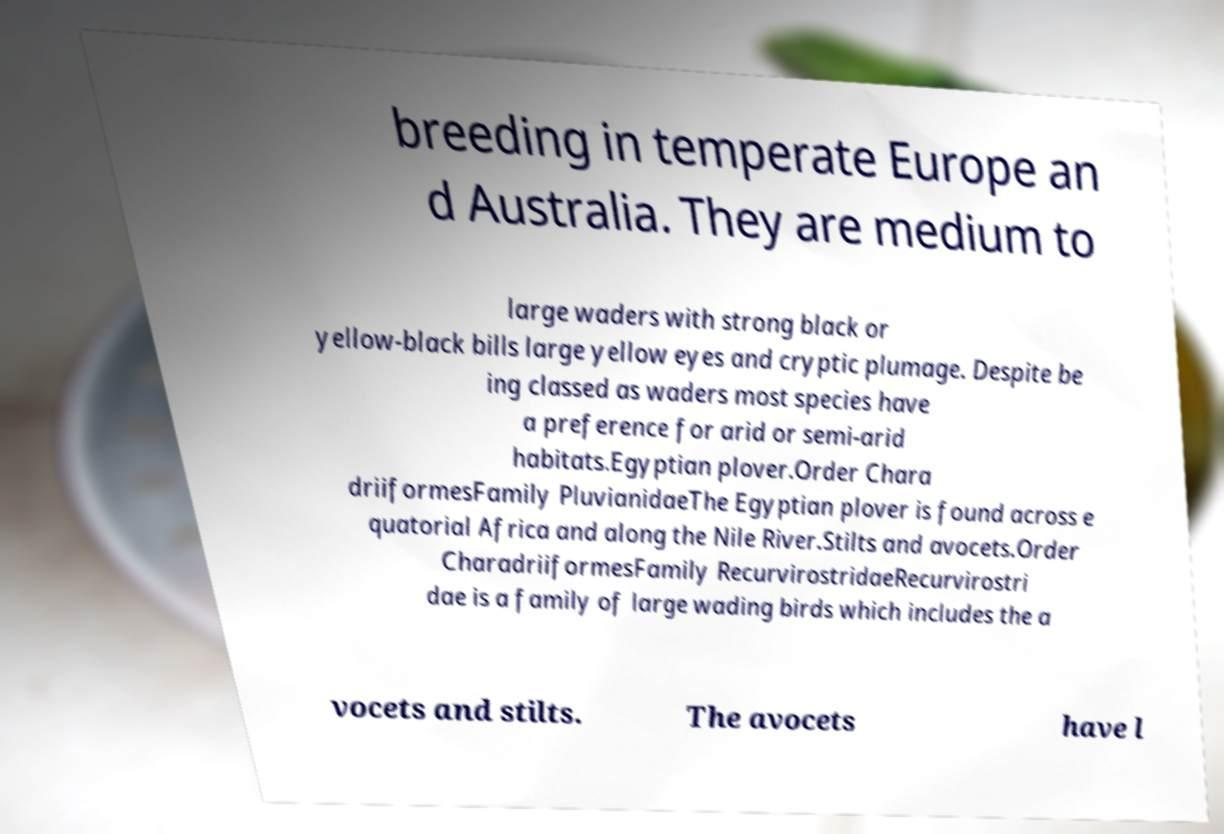Could you assist in decoding the text presented in this image and type it out clearly? breeding in temperate Europe an d Australia. They are medium to large waders with strong black or yellow-black bills large yellow eyes and cryptic plumage. Despite be ing classed as waders most species have a preference for arid or semi-arid habitats.Egyptian plover.Order Chara driiformesFamily PluvianidaeThe Egyptian plover is found across e quatorial Africa and along the Nile River.Stilts and avocets.Order CharadriiformesFamily RecurvirostridaeRecurvirostri dae is a family of large wading birds which includes the a vocets and stilts. The avocets have l 